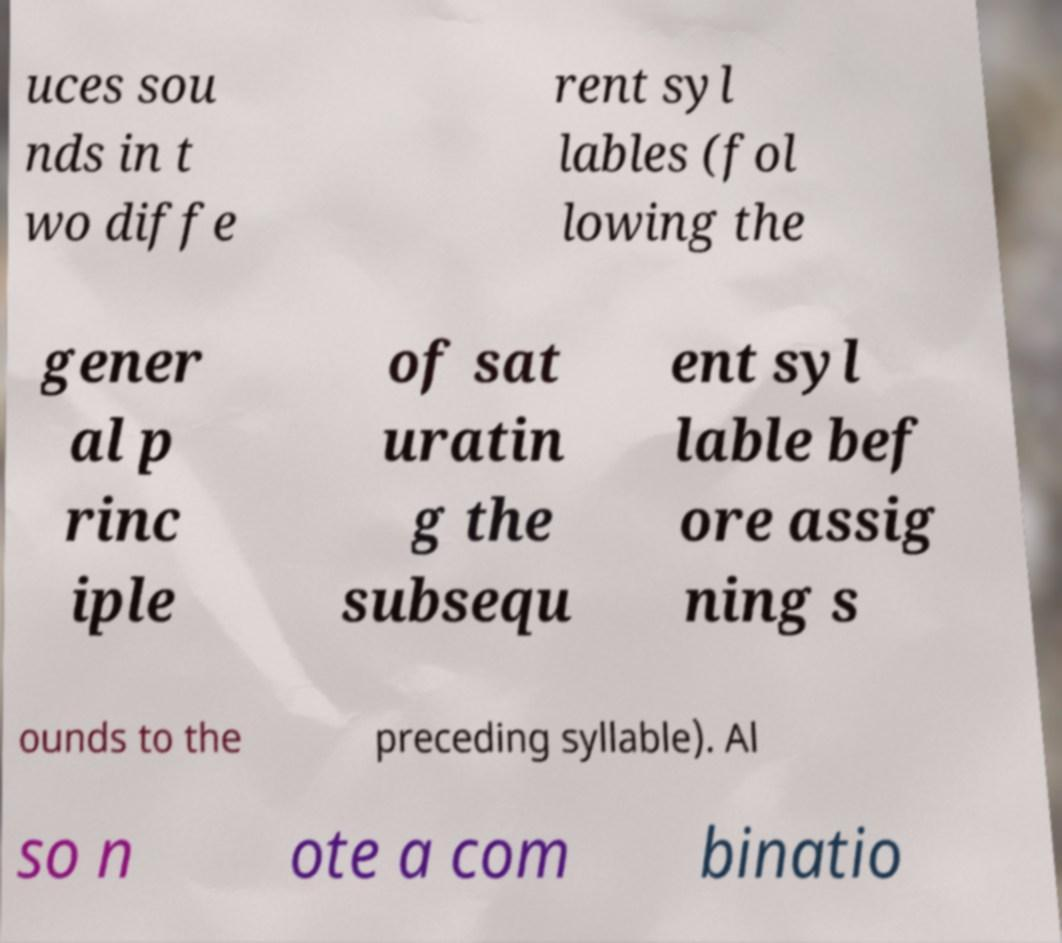For documentation purposes, I need the text within this image transcribed. Could you provide that? uces sou nds in t wo diffe rent syl lables (fol lowing the gener al p rinc iple of sat uratin g the subsequ ent syl lable bef ore assig ning s ounds to the preceding syllable). Al so n ote a com binatio 